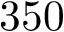Convert formula to latex. <formula><loc_0><loc_0><loc_500><loc_500>3 5 0</formula> 